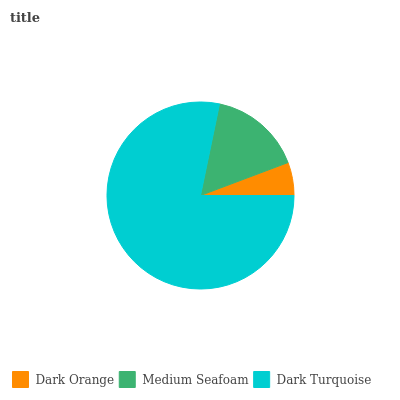Is Dark Orange the minimum?
Answer yes or no. Yes. Is Dark Turquoise the maximum?
Answer yes or no. Yes. Is Medium Seafoam the minimum?
Answer yes or no. No. Is Medium Seafoam the maximum?
Answer yes or no. No. Is Medium Seafoam greater than Dark Orange?
Answer yes or no. Yes. Is Dark Orange less than Medium Seafoam?
Answer yes or no. Yes. Is Dark Orange greater than Medium Seafoam?
Answer yes or no. No. Is Medium Seafoam less than Dark Orange?
Answer yes or no. No. Is Medium Seafoam the high median?
Answer yes or no. Yes. Is Medium Seafoam the low median?
Answer yes or no. Yes. Is Dark Turquoise the high median?
Answer yes or no. No. Is Dark Orange the low median?
Answer yes or no. No. 